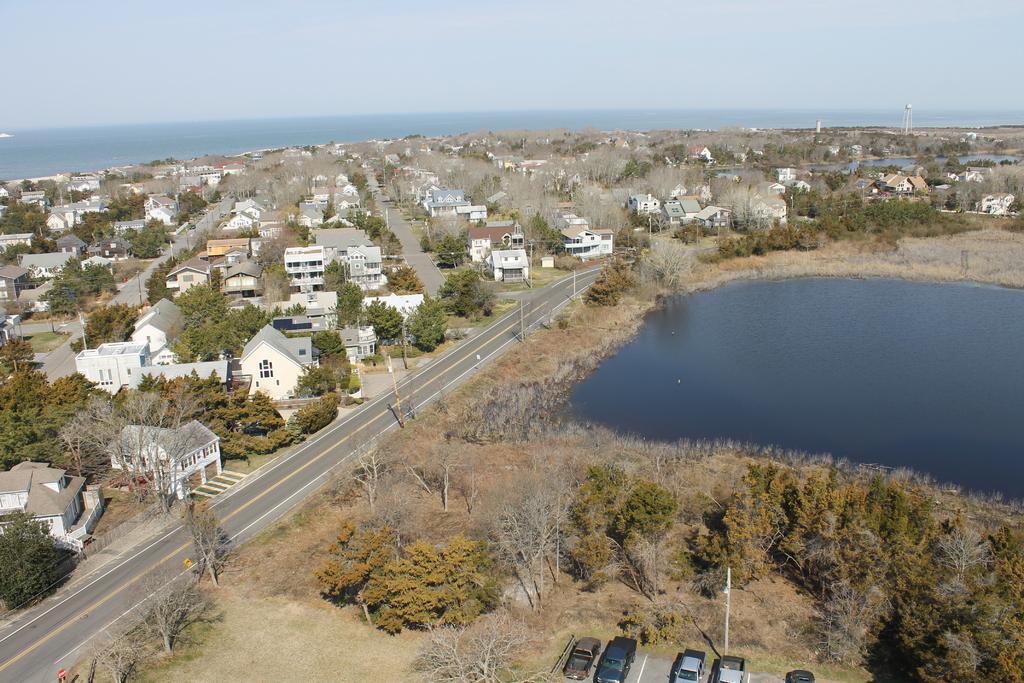What is the main feature of the image? There is a road in the image. What can be seen alongside the road? There are trees in the image. What else is visible in the image? There is water visible in the image, as well as buildings with windows and cars. What is visible in the background of the image? The sky is visible in the background of the image. What type of canvas is being used to paint the rainstorm in the image? There is no rainstorm or canvas present in the image; it features a road, trees, water, buildings, cars, and the sky. 